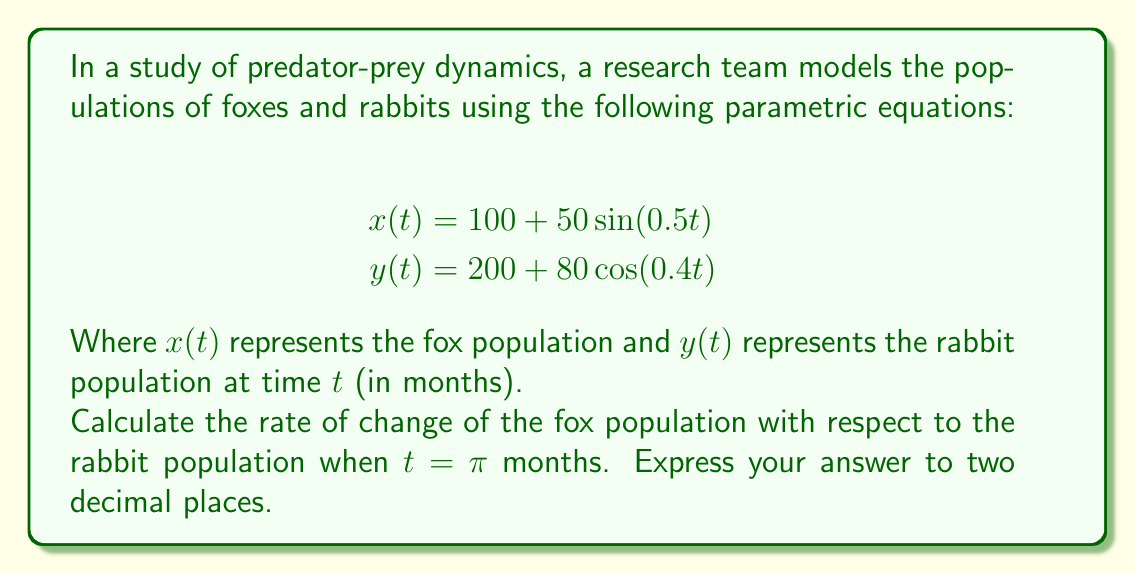Give your solution to this math problem. To solve this problem, we need to follow these steps:

1) First, we need to find $\frac{dx}{dt}$ and $\frac{dy}{dt}$:

   $$\frac{dx}{dt} = 25\cos(0.5t)$$
   $$\frac{dy}{dt} = -32\sin(0.4t)$$

2) We can find $\frac{dx}{dy}$ using the chain rule:

   $$\frac{dx}{dy} = \frac{dx/dt}{dy/dt}$$

3) Now, let's evaluate these at $t = \pi$:

   $$\frac{dx}{dt}\bigg|_{t=\pi} = 25\cos(0.5\pi) = 0$$
   
   $$\frac{dy}{dt}\bigg|_{t=\pi} = -32\sin(0.4\pi) \approx -29.90$$

4) Therefore:

   $$\frac{dx}{dy}\bigg|_{t=\pi} = \frac{0}{-29.90} = 0$$

This result indicates that when $t = \pi$ months, the fox population is not changing with respect to the rabbit population. This could represent a turning point in the predator-prey relationship.
Answer: $0.00$ 